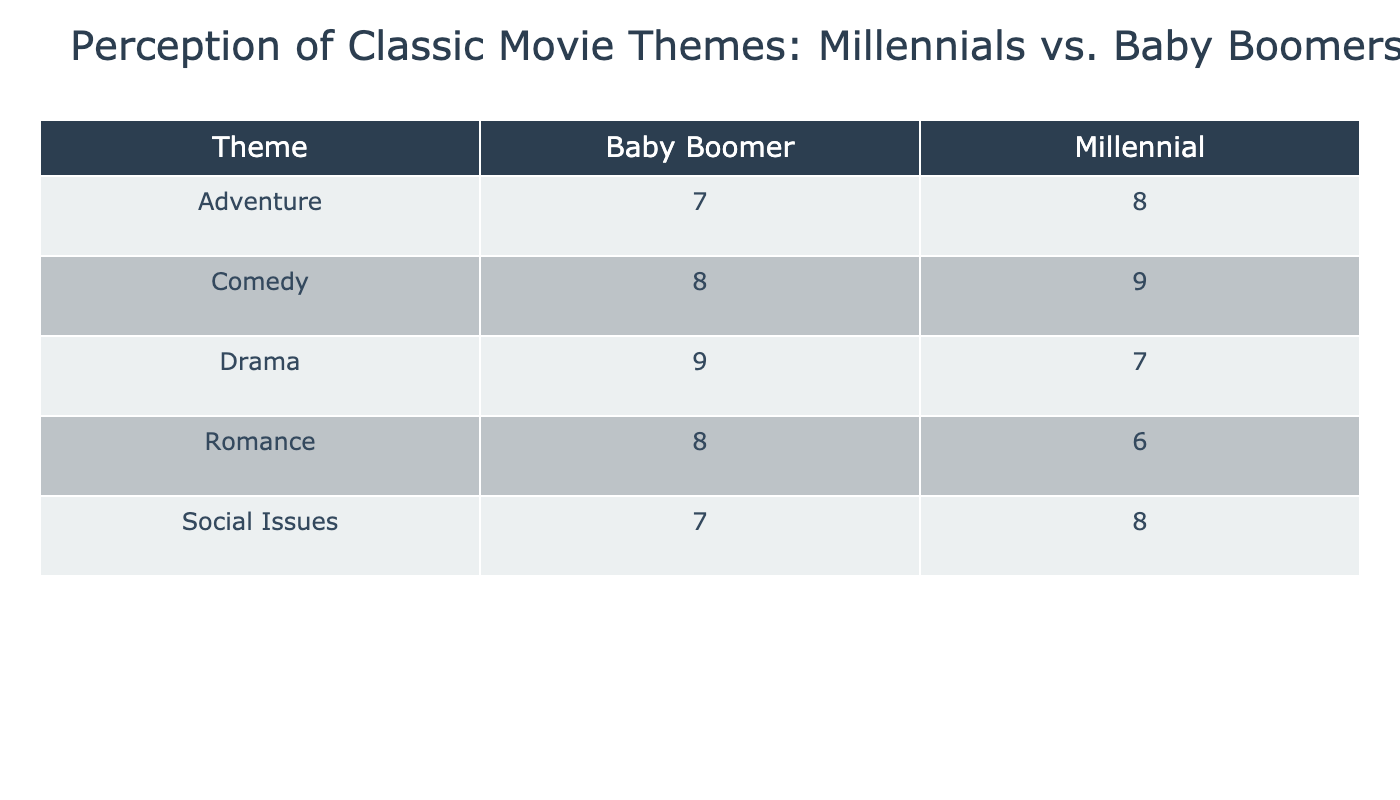What is the perception score for Comedy among Baby Boomers? The table shows that the perception score for the theme Comedy under the Baby Boomer age group is listed directly. The value is 8.
Answer: 8 What is the highest perception score for Millennials among the themes listed? Looking at the Millennial row for each theme, the highest score is found in the Comedy category, which has a score of 9.
Answer: 9 Which age group has a higher perception score for Romance, and what is the score? By comparing the scores for Romance, Baby Boomers are 8 while Millennials are 6. Baby Boomers have the higher score, which is 8.
Answer: Baby Boomers have a higher score of 8 What is the average perception score for Social Issues across both age groups? First, get the scores: Baby Boomers have a score of 7, and Millennials have a score of 8. Adding them up results in 15, and dividing by 2 gives an average of 7.5.
Answer: 7.5 Is the perception score for Adventure higher among Millennials than Baby Boomers? The Adventure score for Millennials is 8, whereas for Baby Boomers, it is 7. Thus, Millennials have a higher score.
Answer: Yes What is the total perception score for Drama across both age groups? The perception score for Drama is 9 for Baby Boomers and 7 for Millennials. When summed, 9 + 7 = 16 gives a total score of 16 across both age groups.
Answer: 16 Which theme received the lowest combined perception score from both age groups? The lowest score is found by adding Baby Boomers' score of 7 (for Social Issues) and Millennials' score of 8 (for Romance), which is 15. Social Issues by Baby Boomers thus is the lowest with a combined score of 15.
Answer: Social Issues, with a score of 15 How many themes have a higher perception score for Millennials compared to Baby Boomers? By reviewing the scores: Adventure and Comedy have higher scores for Millennials (8 and 9, respectively) over Baby Boomers (7 and 8). Thus, there are two themes where this is the case.
Answer: 2 